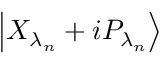<formula> <loc_0><loc_0><loc_500><loc_500>\left | { { X } _ { { \lambda } _ { n } } } + i { { P } _ { { \lambda } _ { n } } } \right \rangle</formula> 